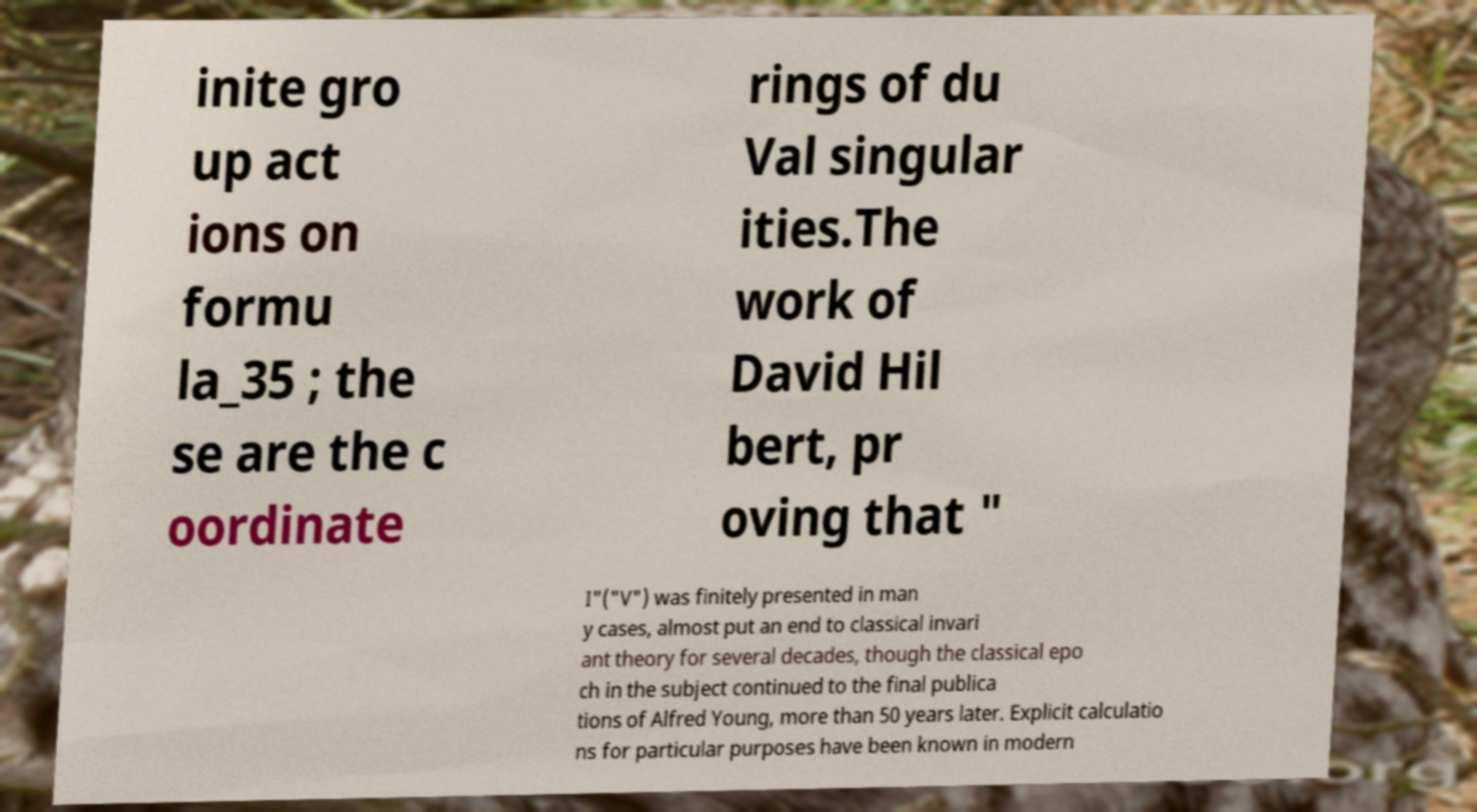There's text embedded in this image that I need extracted. Can you transcribe it verbatim? inite gro up act ions on formu la_35 ; the se are the c oordinate rings of du Val singular ities.The work of David Hil bert, pr oving that " I"("V") was finitely presented in man y cases, almost put an end to classical invari ant theory for several decades, though the classical epo ch in the subject continued to the final publica tions of Alfred Young, more than 50 years later. Explicit calculatio ns for particular purposes have been known in modern 